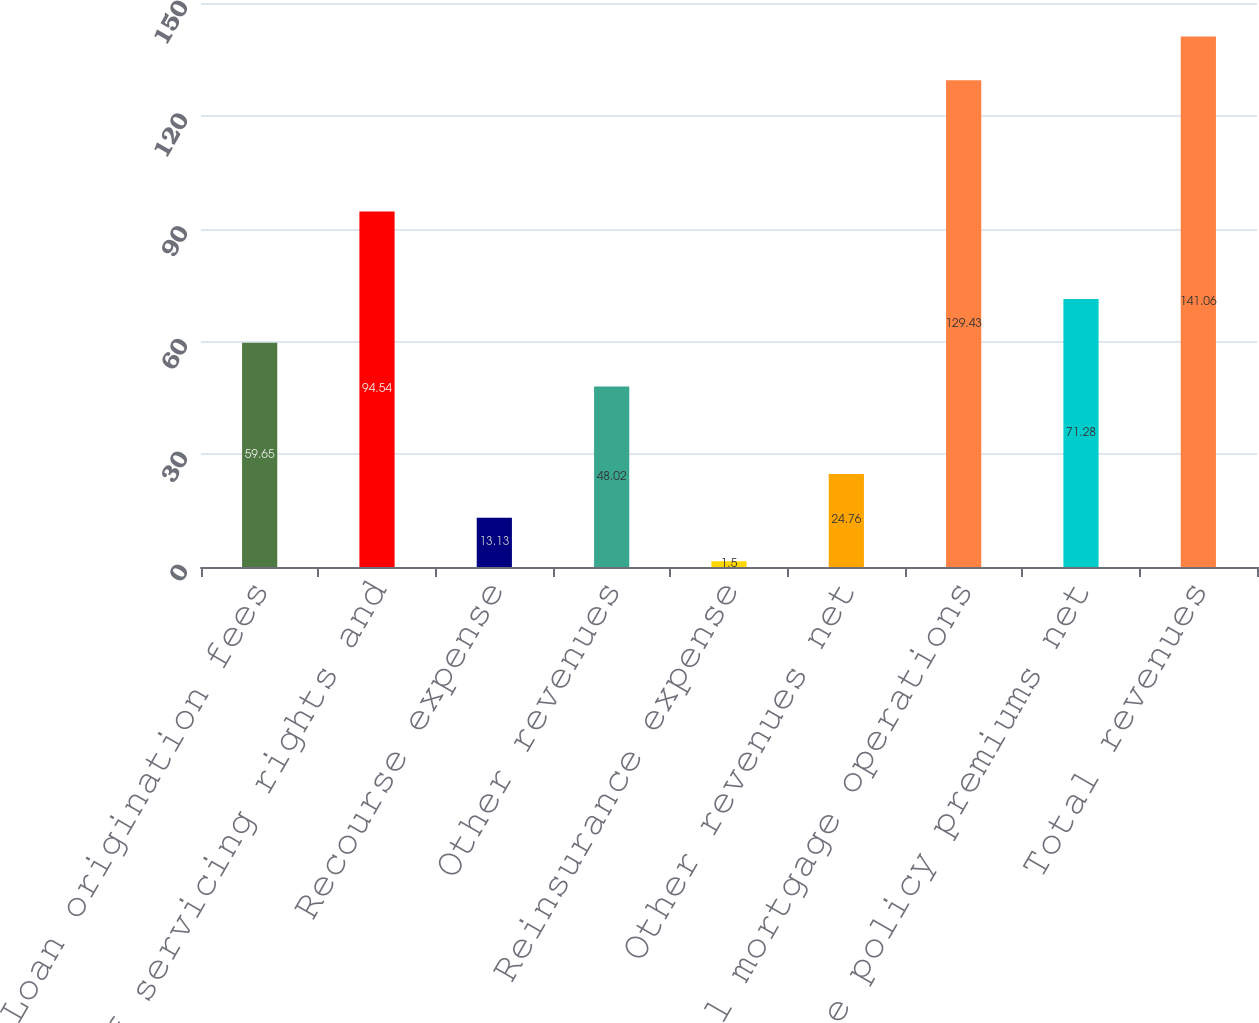Convert chart to OTSL. <chart><loc_0><loc_0><loc_500><loc_500><bar_chart><fcel>Loan origination fees<fcel>Sale of servicing rights and<fcel>Recourse expense<fcel>Other revenues<fcel>Reinsurance expense<fcel>Other revenues net<fcel>Total mortgage operations<fcel>Title policy premiums net<fcel>Total revenues<nl><fcel>59.65<fcel>94.54<fcel>13.13<fcel>48.02<fcel>1.5<fcel>24.76<fcel>129.43<fcel>71.28<fcel>141.06<nl></chart> 